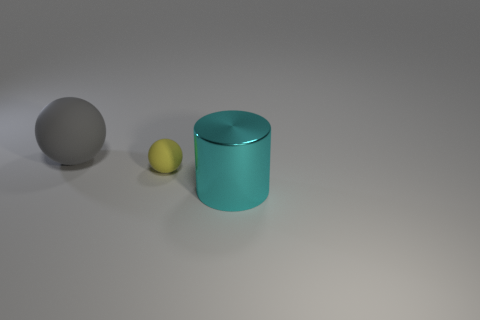There is a yellow object; what shape is it?
Make the answer very short. Sphere. The object that is both behind the cyan cylinder and in front of the gray rubber ball is made of what material?
Give a very brief answer. Rubber. There is a thing that is the same material as the big ball; what size is it?
Provide a succinct answer. Small. What shape is the object that is both to the right of the gray matte object and to the left of the cyan cylinder?
Ensure brevity in your answer.  Sphere. There is a metallic thing that is right of the sphere that is behind the yellow sphere; what size is it?
Offer a very short reply. Large. What is the material of the yellow thing?
Keep it short and to the point. Rubber. Are any small red metallic balls visible?
Give a very brief answer. No. Are there an equal number of matte spheres that are in front of the gray object and large cyan shiny things?
Offer a terse response. Yes. Is there anything else that has the same material as the large cyan object?
Ensure brevity in your answer.  No. What number of large things are matte balls or yellow objects?
Make the answer very short. 1. 